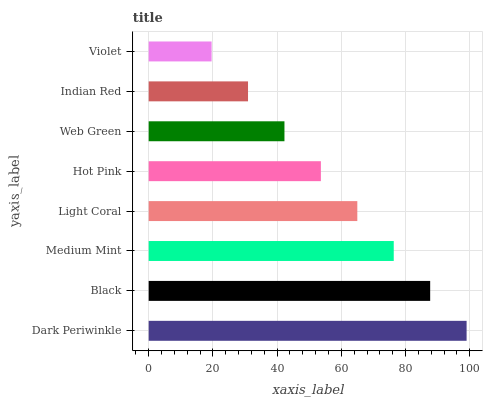Is Violet the minimum?
Answer yes or no. Yes. Is Dark Periwinkle the maximum?
Answer yes or no. Yes. Is Black the minimum?
Answer yes or no. No. Is Black the maximum?
Answer yes or no. No. Is Dark Periwinkle greater than Black?
Answer yes or no. Yes. Is Black less than Dark Periwinkle?
Answer yes or no. Yes. Is Black greater than Dark Periwinkle?
Answer yes or no. No. Is Dark Periwinkle less than Black?
Answer yes or no. No. Is Light Coral the high median?
Answer yes or no. Yes. Is Hot Pink the low median?
Answer yes or no. Yes. Is Medium Mint the high median?
Answer yes or no. No. Is Violet the low median?
Answer yes or no. No. 